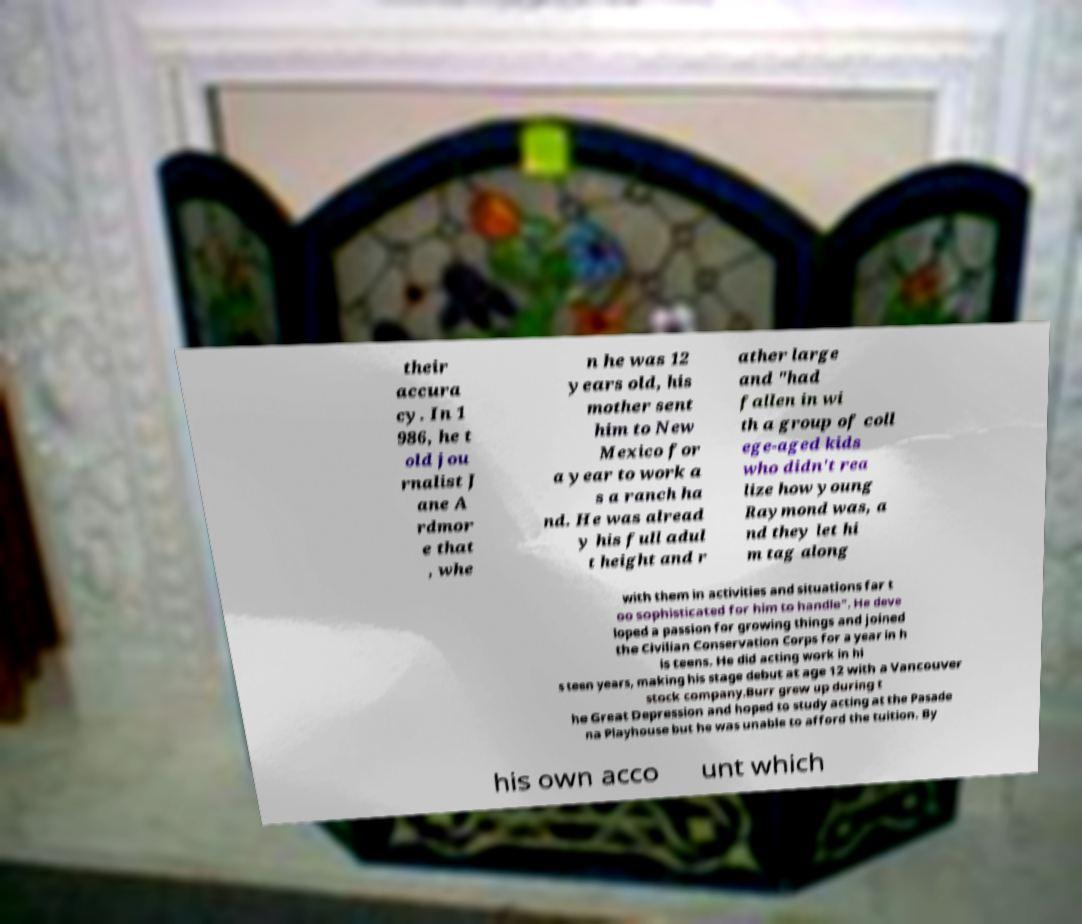There's text embedded in this image that I need extracted. Can you transcribe it verbatim? their accura cy. In 1 986, he t old jou rnalist J ane A rdmor e that , whe n he was 12 years old, his mother sent him to New Mexico for a year to work a s a ranch ha nd. He was alread y his full adul t height and r ather large and "had fallen in wi th a group of coll ege-aged kids who didn't rea lize how young Raymond was, a nd they let hi m tag along with them in activities and situations far t oo sophisticated for him to handle". He deve loped a passion for growing things and joined the Civilian Conservation Corps for a year in h is teens. He did acting work in hi s teen years, making his stage debut at age 12 with a Vancouver stock company.Burr grew up during t he Great Depression and hoped to study acting at the Pasade na Playhouse but he was unable to afford the tuition. By his own acco unt which 